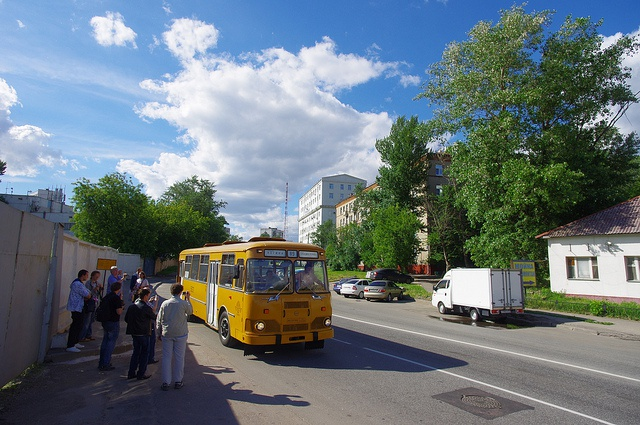Describe the objects in this image and their specific colors. I can see bus in lightblue, maroon, black, gray, and orange tones, truck in lightblue, white, gray, and black tones, people in lightblue, gray, navy, black, and darkblue tones, people in lightblue, black, maroon, and gray tones, and people in lightblue, black, maroon, navy, and gray tones in this image. 